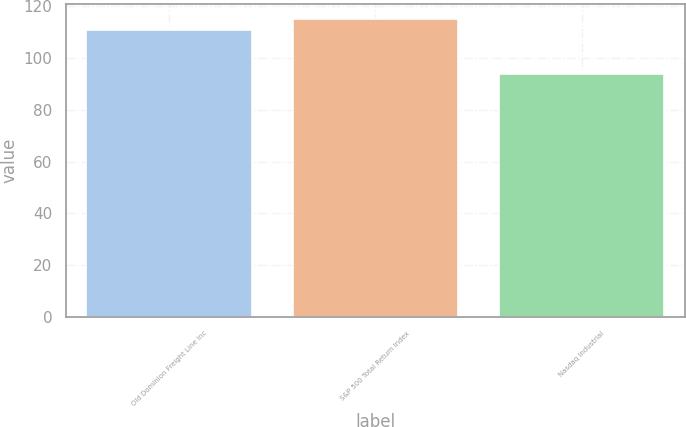Convert chart to OTSL. <chart><loc_0><loc_0><loc_500><loc_500><bar_chart><fcel>Old Dominion Freight Line Inc<fcel>S&P 500 Total Return Index<fcel>Nasdaq Industrial<nl><fcel>111<fcel>115<fcel>94<nl></chart> 